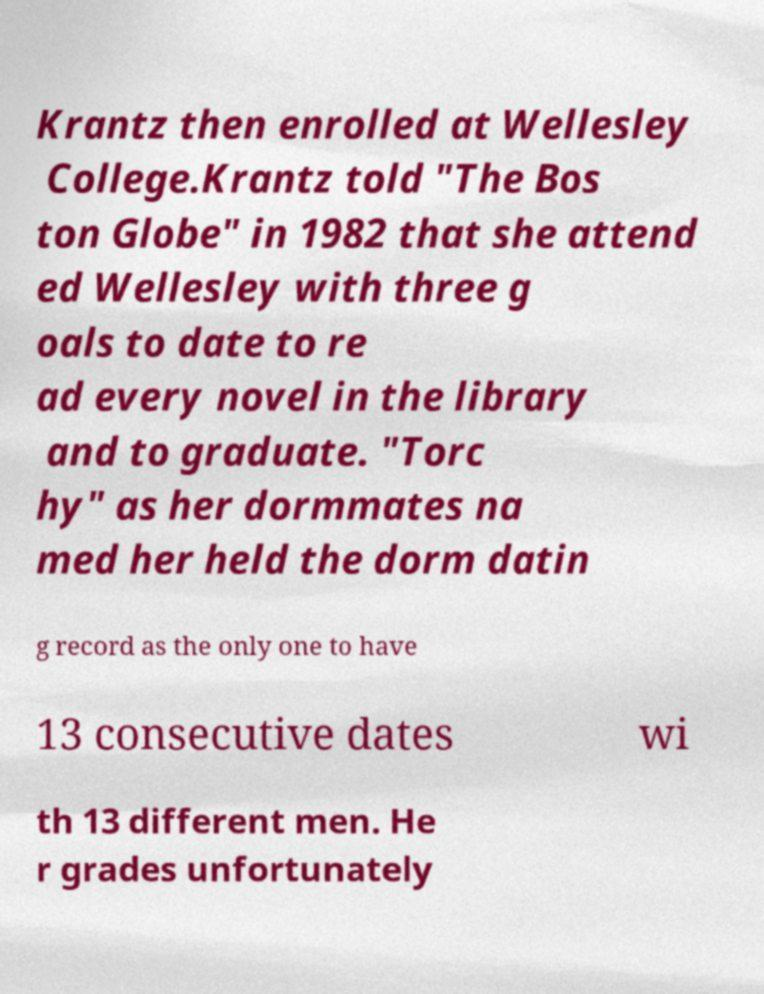Could you extract and type out the text from this image? Krantz then enrolled at Wellesley College.Krantz told "The Bos ton Globe" in 1982 that she attend ed Wellesley with three g oals to date to re ad every novel in the library and to graduate. "Torc hy" as her dormmates na med her held the dorm datin g record as the only one to have 13 consecutive dates wi th 13 different men. He r grades unfortunately 